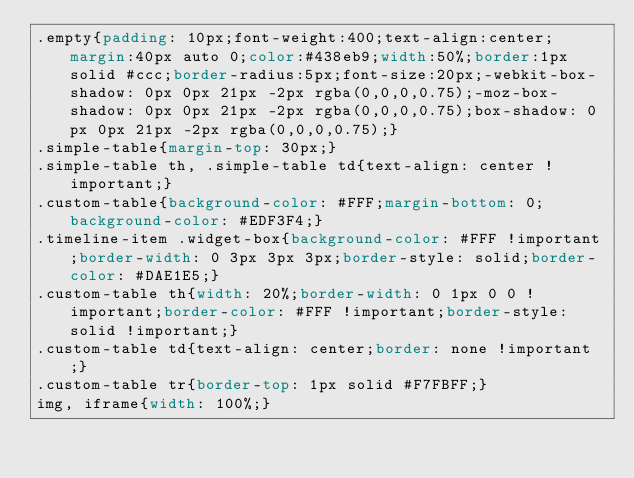<code> <loc_0><loc_0><loc_500><loc_500><_CSS_>.empty{padding: 10px;font-weight:400;text-align:center;margin:40px auto 0;color:#438eb9;width:50%;border:1px solid #ccc;border-radius:5px;font-size:20px;-webkit-box-shadow: 0px 0px 21px -2px rgba(0,0,0,0.75);-moz-box-shadow: 0px 0px 21px -2px rgba(0,0,0,0.75);box-shadow: 0px 0px 21px -2px rgba(0,0,0,0.75);}
.simple-table{margin-top: 30px;}
.simple-table th, .simple-table td{text-align: center !important;} 
.custom-table{background-color: #FFF;margin-bottom: 0;background-color: #EDF3F4;}
.timeline-item .widget-box{background-color: #FFF !important;border-width: 0 3px 3px 3px;border-style: solid;border-color: #DAE1E5;}
.custom-table th{width: 20%;border-width: 0 1px 0 0 !important;border-color: #FFF !important;border-style: solid !important;}
.custom-table td{text-align: center;border: none !important;}
.custom-table tr{border-top: 1px solid #F7FBFF;}
img, iframe{width: 100%;}
</code> 